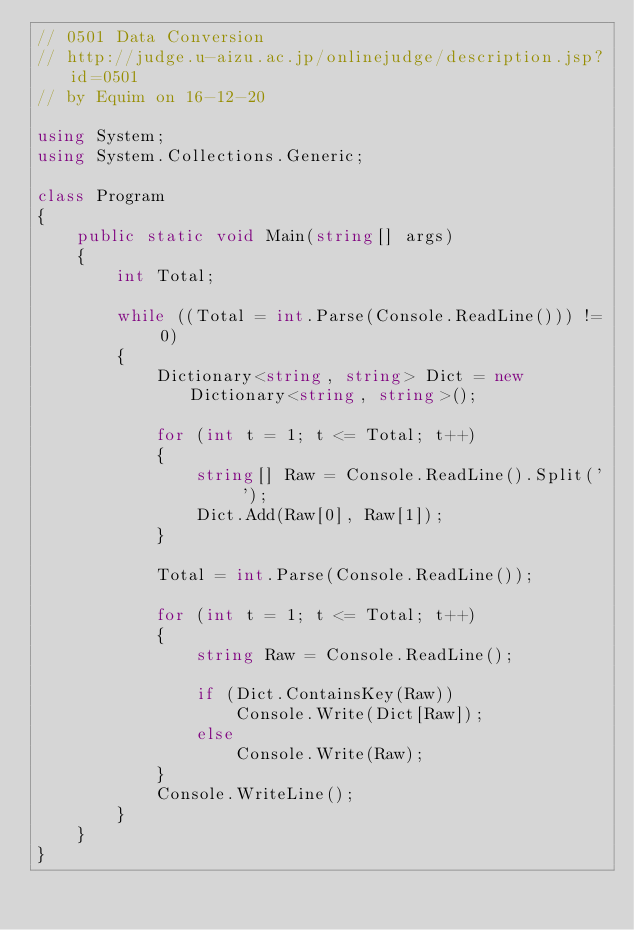<code> <loc_0><loc_0><loc_500><loc_500><_C#_>// 0501 Data Conversion
// http://judge.u-aizu.ac.jp/onlinejudge/description.jsp?id=0501
// by Equim on 16-12-20

using System;
using System.Collections.Generic;

class Program
{
    public static void Main(string[] args)
    {
        int Total;

        while ((Total = int.Parse(Console.ReadLine())) != 0)
        {
            Dictionary<string, string> Dict = new Dictionary<string, string>();

            for (int t = 1; t <= Total; t++)
            {
                string[] Raw = Console.ReadLine().Split(' ');
                Dict.Add(Raw[0], Raw[1]);
            }

            Total = int.Parse(Console.ReadLine());

            for (int t = 1; t <= Total; t++)
            {
                string Raw = Console.ReadLine();

                if (Dict.ContainsKey(Raw))
                    Console.Write(Dict[Raw]);
                else
                    Console.Write(Raw);
            }
            Console.WriteLine();
        }
    }
}</code> 